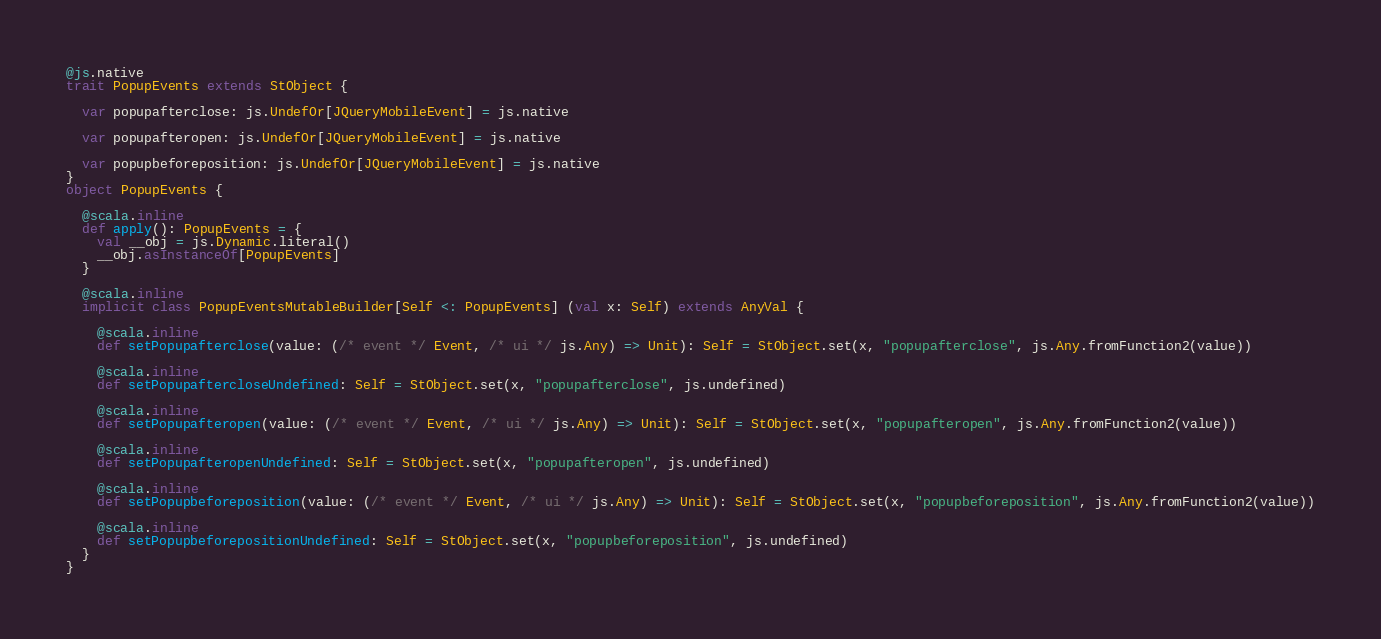<code> <loc_0><loc_0><loc_500><loc_500><_Scala_>@js.native
trait PopupEvents extends StObject {
  
  var popupafterclose: js.UndefOr[JQueryMobileEvent] = js.native
  
  var popupafteropen: js.UndefOr[JQueryMobileEvent] = js.native
  
  var popupbeforeposition: js.UndefOr[JQueryMobileEvent] = js.native
}
object PopupEvents {
  
  @scala.inline
  def apply(): PopupEvents = {
    val __obj = js.Dynamic.literal()
    __obj.asInstanceOf[PopupEvents]
  }
  
  @scala.inline
  implicit class PopupEventsMutableBuilder[Self <: PopupEvents] (val x: Self) extends AnyVal {
    
    @scala.inline
    def setPopupafterclose(value: (/* event */ Event, /* ui */ js.Any) => Unit): Self = StObject.set(x, "popupafterclose", js.Any.fromFunction2(value))
    
    @scala.inline
    def setPopupaftercloseUndefined: Self = StObject.set(x, "popupafterclose", js.undefined)
    
    @scala.inline
    def setPopupafteropen(value: (/* event */ Event, /* ui */ js.Any) => Unit): Self = StObject.set(x, "popupafteropen", js.Any.fromFunction2(value))
    
    @scala.inline
    def setPopupafteropenUndefined: Self = StObject.set(x, "popupafteropen", js.undefined)
    
    @scala.inline
    def setPopupbeforeposition(value: (/* event */ Event, /* ui */ js.Any) => Unit): Self = StObject.set(x, "popupbeforeposition", js.Any.fromFunction2(value))
    
    @scala.inline
    def setPopupbeforepositionUndefined: Self = StObject.set(x, "popupbeforeposition", js.undefined)
  }
}
</code> 